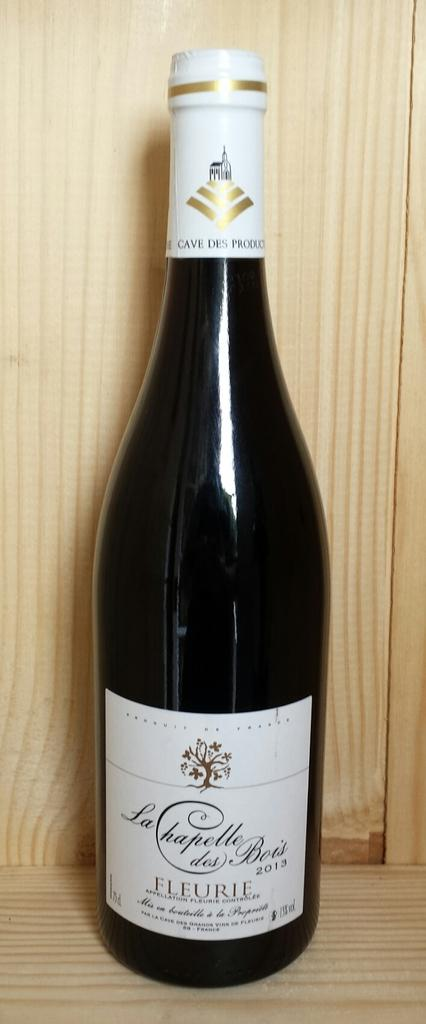Provide a one-sentence caption for the provided image. A WINE BOTTLE WITH A WHITE LABEL THAT SAYS "LA CHAPELLE DES BOIS 2013 FLEURIE". 